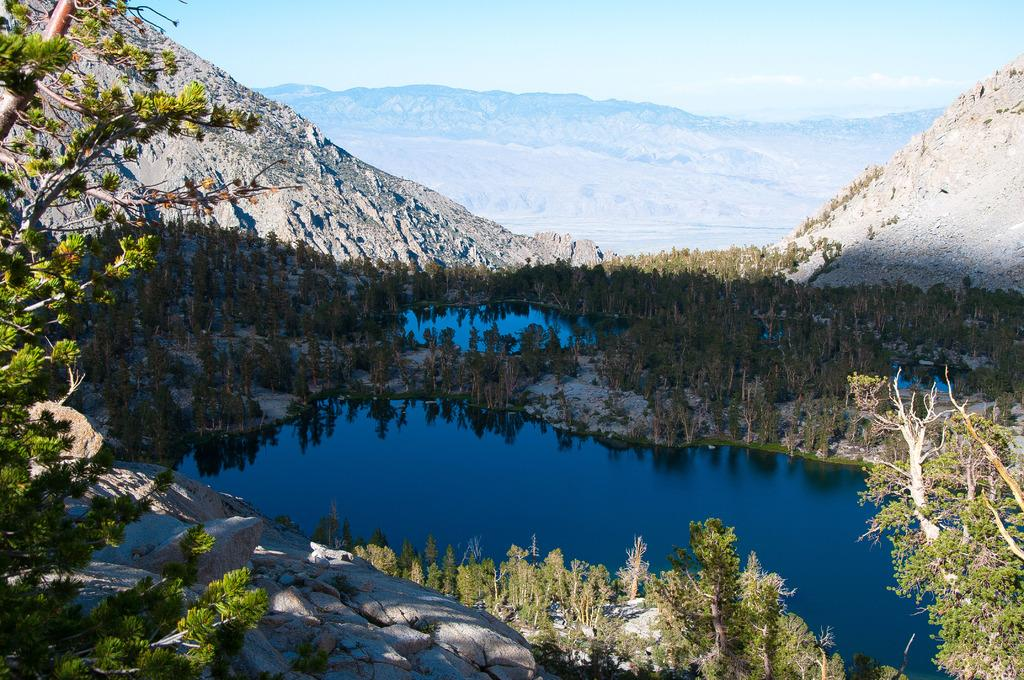What type of scenery is depicted in the image? The image depicts a beautiful scenery. What kind of vegetation can be seen in the image? There are many plants in the image. What geographical features are present in the image? There are mountains, a river, and a pond in the image. Where is the lunchroom located in the image? There is no lunchroom present in the image; it is a natural scenery with plants, mountains, a river, and a pond. What type of spot is visible on the mountains in the image? There is no specific spot mentioned or visible on the mountains in the image. 